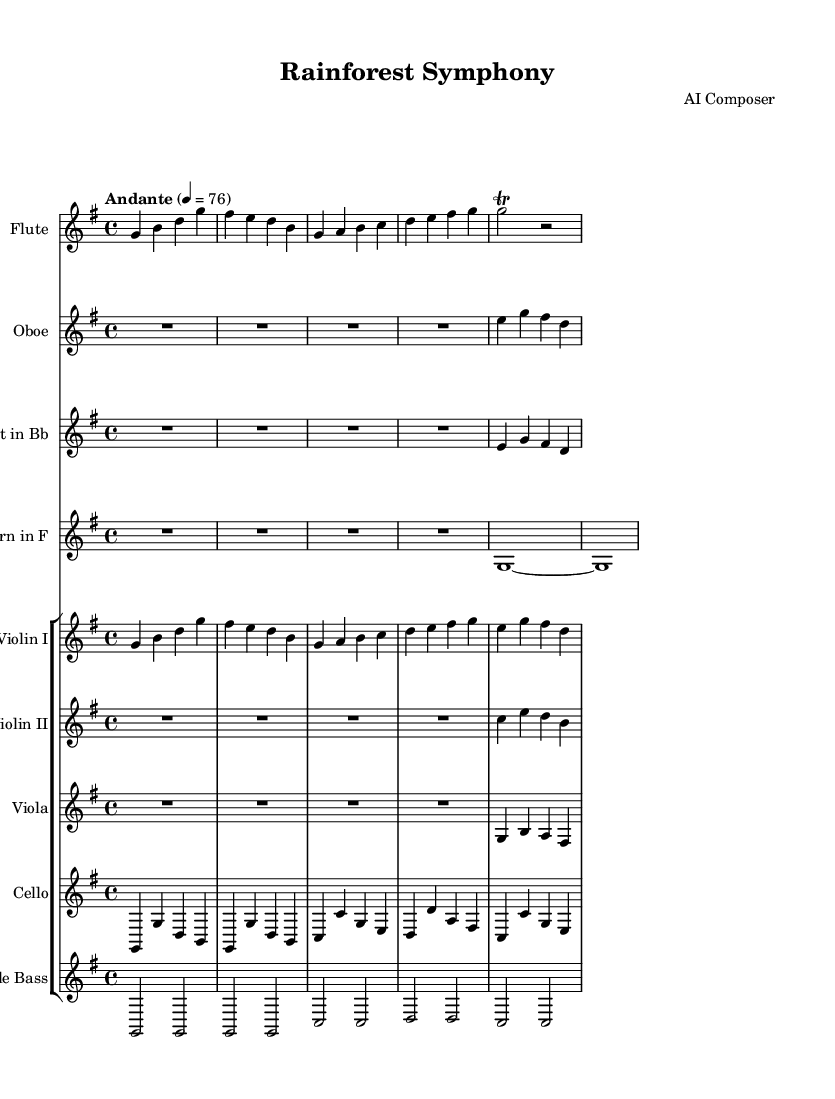What is the key signature of this music? The key signature indicated in the global context shows that there is an F sharp and a C sharp, which means the key is G major.
Answer: G major What is the time signature of this music? The time signature is indicated right after the key signature in the global context as 4/4, meaning there are four beats in each measure and the quarter note gets one beat.
Answer: 4/4 What is the tempo marking for this composition? The tempo marking is found in the global context; it specifies "Andante" with a metronome marking of 76, which indicates a moderately slow tempo.
Answer: Andante, 76 Which instruments are included in this composition? The instruments are listed in the score section: Flute, Oboe, Clarinet in Bb, Horn in F, Violin I, Violin II, Viola, Cello, and Double Bass, making up the orchestration.
Answer: Flute, Oboe, Clarinet in Bb, Horn in F, Violin I, Violin II, Viola, Cello, Double Bass How many measures are in the flute part? The flute part consists of five measures, as indicated by the groups of notes and their respective bars. The last measure is a trill followed by a rest.
Answer: Five measures What texture is predominantly used throughout the "Rainforest Symphony"? Observing the interactions between the instruments, the composition exhibits a homophonic texture where the flute often leads, supported by harmonies from the strings, creating a lush layered sound.
Answer: Homophonic What thematic elements suggest a celebration of animal habitats? The melodic lines created in the flute part and the rhythmic variations contribute to a lively and colorful representation, evoking the beauty and diversity found in rainforest habitats, suggesting life and vibrancy.
Answer: Lively and colorful 